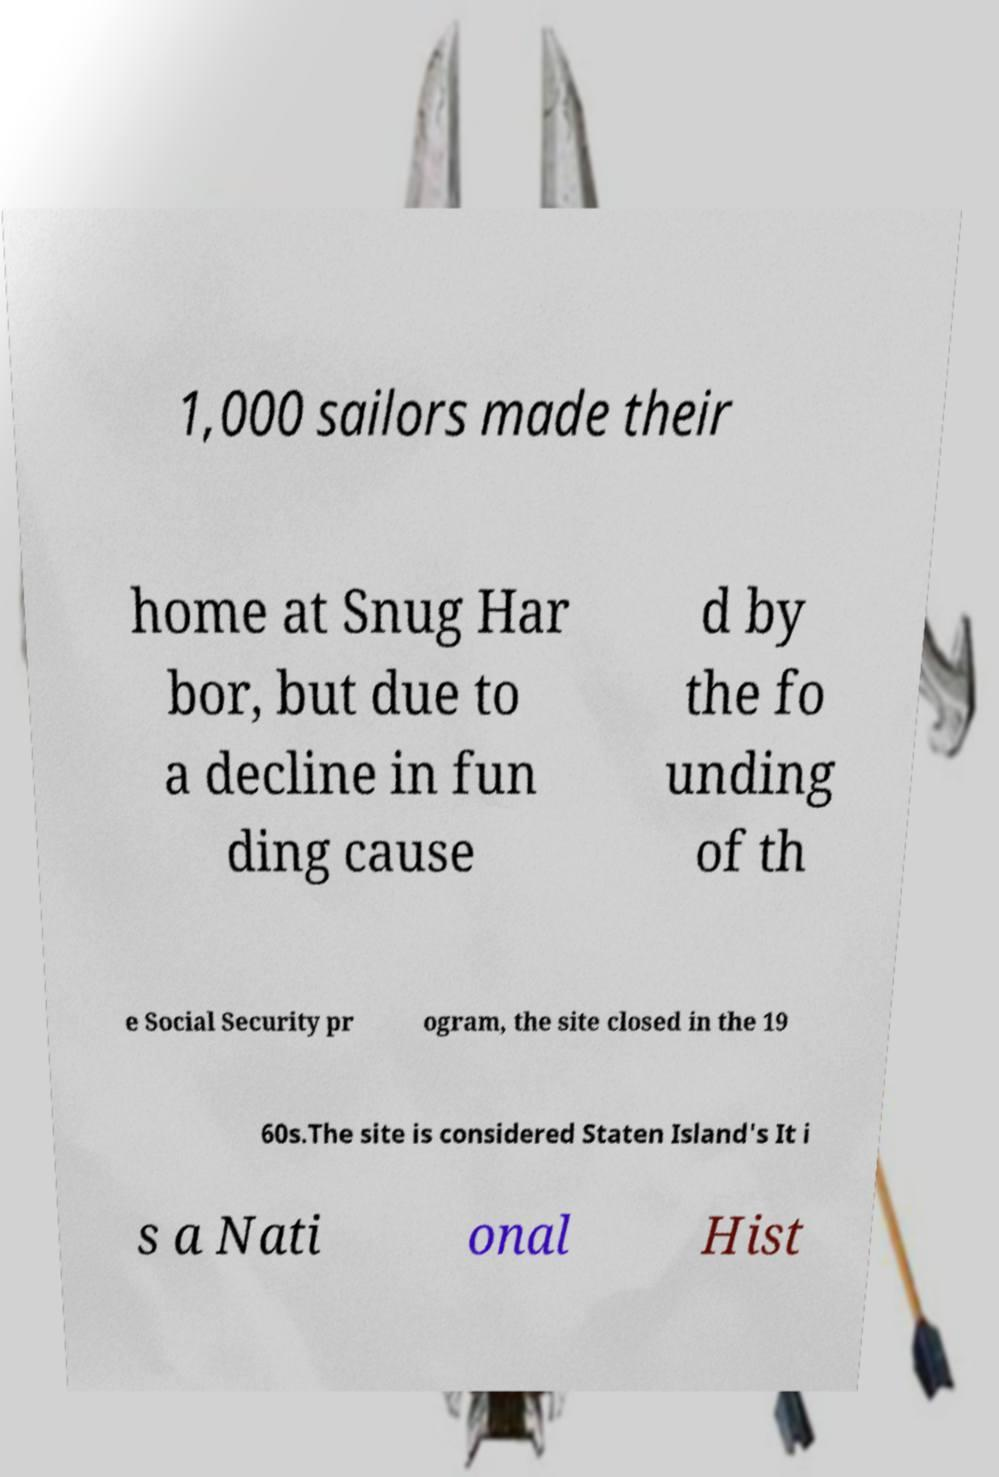Could you extract and type out the text from this image? 1,000 sailors made their home at Snug Har bor, but due to a decline in fun ding cause d by the fo unding of th e Social Security pr ogram, the site closed in the 19 60s.The site is considered Staten Island's It i s a Nati onal Hist 